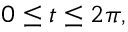Convert formula to latex. <formula><loc_0><loc_0><loc_500><loc_500>0 \leq t \leq 2 \pi ,</formula> 